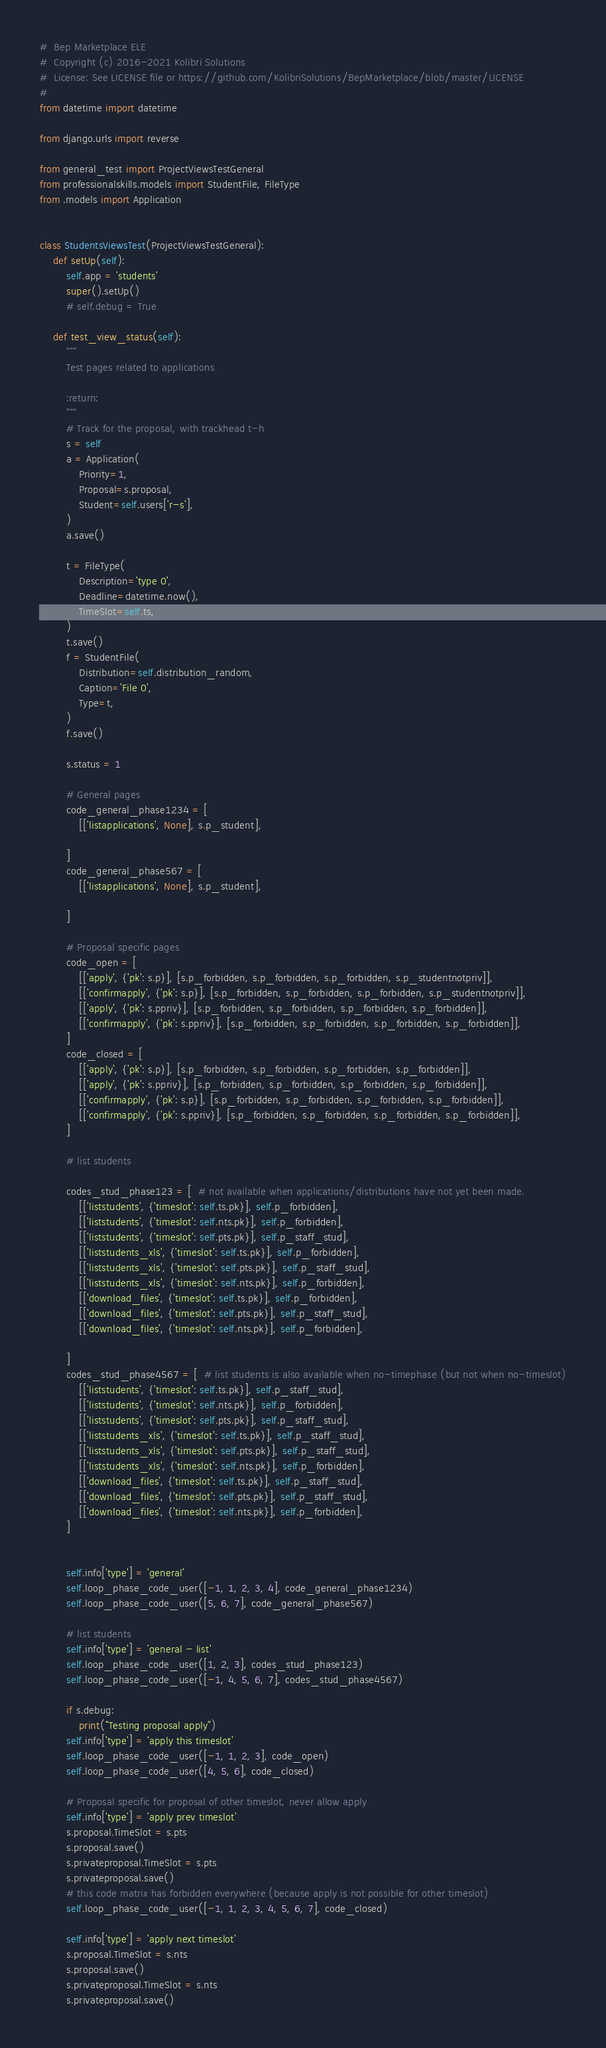<code> <loc_0><loc_0><loc_500><loc_500><_Python_>#  Bep Marketplace ELE
#  Copyright (c) 2016-2021 Kolibri Solutions
#  License: See LICENSE file or https://github.com/KolibriSolutions/BepMarketplace/blob/master/LICENSE
#
from datetime import datetime

from django.urls import reverse

from general_test import ProjectViewsTestGeneral
from professionalskills.models import StudentFile, FileType
from .models import Application


class StudentsViewsTest(ProjectViewsTestGeneral):
    def setUp(self):
        self.app = 'students'
        super().setUp()
        # self.debug = True

    def test_view_status(self):
        """
        Test pages related to applications

        :return:
        """
        # Track for the proposal, with trackhead t-h
        s = self
        a = Application(
            Priority=1,
            Proposal=s.proposal,
            Student=self.users['r-s'],
        )
        a.save()

        t = FileType(
            Description='type 0',
            Deadline=datetime.now(),
            TimeSlot=self.ts,
        )
        t.save()
        f = StudentFile(
            Distribution=self.distribution_random,
            Caption='File 0',
            Type=t,
        )
        f.save()

        s.status = 1

        # General pages
        code_general_phase1234 = [
            [['listapplications', None], s.p_student],

        ]
        code_general_phase567 = [
            [['listapplications', None], s.p_student],

        ]

        # Proposal specific pages
        code_open = [
            [['apply', {'pk': s.p}], [s.p_forbidden, s.p_forbidden, s.p_forbidden, s.p_studentnotpriv]],
            [['confirmapply', {'pk': s.p}], [s.p_forbidden, s.p_forbidden, s.p_forbidden, s.p_studentnotpriv]],
            [['apply', {'pk': s.ppriv}], [s.p_forbidden, s.p_forbidden, s.p_forbidden, s.p_forbidden]],
            [['confirmapply', {'pk': s.ppriv}], [s.p_forbidden, s.p_forbidden, s.p_forbidden, s.p_forbidden]],
        ]
        code_closed = [
            [['apply', {'pk': s.p}], [s.p_forbidden, s.p_forbidden, s.p_forbidden, s.p_forbidden]],
            [['apply', {'pk': s.ppriv}], [s.p_forbidden, s.p_forbidden, s.p_forbidden, s.p_forbidden]],
            [['confirmapply', {'pk': s.p}], [s.p_forbidden, s.p_forbidden, s.p_forbidden, s.p_forbidden]],
            [['confirmapply', {'pk': s.ppriv}], [s.p_forbidden, s.p_forbidden, s.p_forbidden, s.p_forbidden]],
        ]

        # list students

        codes_stud_phase123 = [  # not available when applications/distributions have not yet been made.
            [['liststudents', {'timeslot': self.ts.pk}], self.p_forbidden],
            [['liststudents', {'timeslot': self.nts.pk}], self.p_forbidden],
            [['liststudents', {'timeslot': self.pts.pk}], self.p_staff_stud],
            [['liststudents_xls', {'timeslot': self.ts.pk}], self.p_forbidden],
            [['liststudents_xls', {'timeslot': self.pts.pk}], self.p_staff_stud],
            [['liststudents_xls', {'timeslot': self.nts.pk}], self.p_forbidden],
            [['download_files', {'timeslot': self.ts.pk}], self.p_forbidden],
            [['download_files', {'timeslot': self.pts.pk}], self.p_staff_stud],
            [['download_files', {'timeslot': self.nts.pk}], self.p_forbidden],

        ]
        codes_stud_phase4567 = [  # list students is also available when no-timephase (but not when no-timeslot)
            [['liststudents', {'timeslot': self.ts.pk}], self.p_staff_stud],
            [['liststudents', {'timeslot': self.nts.pk}], self.p_forbidden],
            [['liststudents', {'timeslot': self.pts.pk}], self.p_staff_stud],
            [['liststudents_xls', {'timeslot': self.ts.pk}], self.p_staff_stud],
            [['liststudents_xls', {'timeslot': self.pts.pk}], self.p_staff_stud],
            [['liststudents_xls', {'timeslot': self.nts.pk}], self.p_forbidden],
            [['download_files', {'timeslot': self.ts.pk}], self.p_staff_stud],
            [['download_files', {'timeslot': self.pts.pk}], self.p_staff_stud],
            [['download_files', {'timeslot': self.nts.pk}], self.p_forbidden],
        ]


        self.info['type'] = 'general'
        self.loop_phase_code_user([-1, 1, 2, 3, 4], code_general_phase1234)
        self.loop_phase_code_user([5, 6, 7], code_general_phase567)

        # list students
        self.info['type'] = 'general - list'
        self.loop_phase_code_user([1, 2, 3], codes_stud_phase123)
        self.loop_phase_code_user([-1, 4, 5, 6, 7], codes_stud_phase4567)

        if s.debug:
            print("Testing proposal apply")
        self.info['type'] = 'apply this timeslot'
        self.loop_phase_code_user([-1, 1, 2, 3], code_open)
        self.loop_phase_code_user([4, 5, 6], code_closed)

        # Proposal specific for proposal of other timeslot, never allow apply
        self.info['type'] = 'apply prev timeslot'
        s.proposal.TimeSlot = s.pts
        s.proposal.save()
        s.privateproposal.TimeSlot = s.pts
        s.privateproposal.save()
        # this code matrix has forbidden everywhere (because apply is not possible for other timeslot)
        self.loop_phase_code_user([-1, 1, 2, 3, 4, 5, 6, 7], code_closed)

        self.info['type'] = 'apply next timeslot'
        s.proposal.TimeSlot = s.nts
        s.proposal.save()
        s.privateproposal.TimeSlot = s.nts
        s.privateproposal.save()</code> 